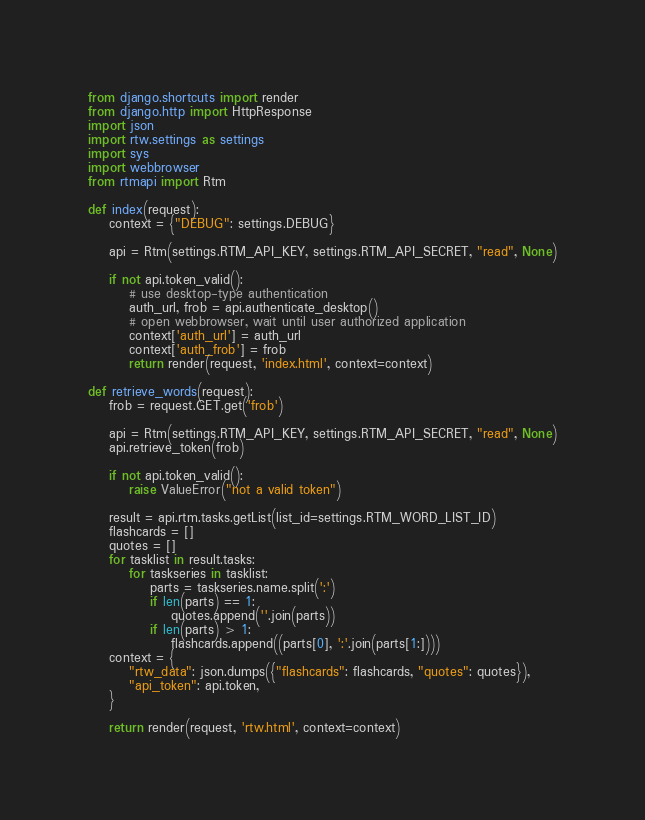<code> <loc_0><loc_0><loc_500><loc_500><_Python_>from django.shortcuts import render
from django.http import HttpResponse
import json
import rtw.settings as settings
import sys
import webbrowser
from rtmapi import Rtm

def index(request):
    context = {"DEBUG": settings.DEBUG}

    api = Rtm(settings.RTM_API_KEY, settings.RTM_API_SECRET, "read", None)

    if not api.token_valid():
        # use desktop-type authentication
        auth_url, frob = api.authenticate_desktop()
        # open webbrowser, wait until user authorized application
        context['auth_url'] = auth_url
        context['auth_frob'] = frob
        return render(request, 'index.html', context=context)

def retrieve_words(request):
    frob = request.GET.get('frob')

    api = Rtm(settings.RTM_API_KEY, settings.RTM_API_SECRET, "read", None)
    api.retrieve_token(frob)

    if not api.token_valid():
        raise ValueError("not a valid token")

    result = api.rtm.tasks.getList(list_id=settings.RTM_WORD_LIST_ID)
    flashcards = []
    quotes = []
    for tasklist in result.tasks:
        for taskseries in tasklist:
            parts = taskseries.name.split(':')
            if len(parts) == 1:
                quotes.append(''.join(parts))
            if len(parts) > 1:
                flashcards.append((parts[0], ':'.join(parts[1:])))
    context = {
        "rtw_data": json.dumps({"flashcards": flashcards, "quotes": quotes}),
        "api_token": api.token,
    }

    return render(request, 'rtw.html', context=context)
</code> 